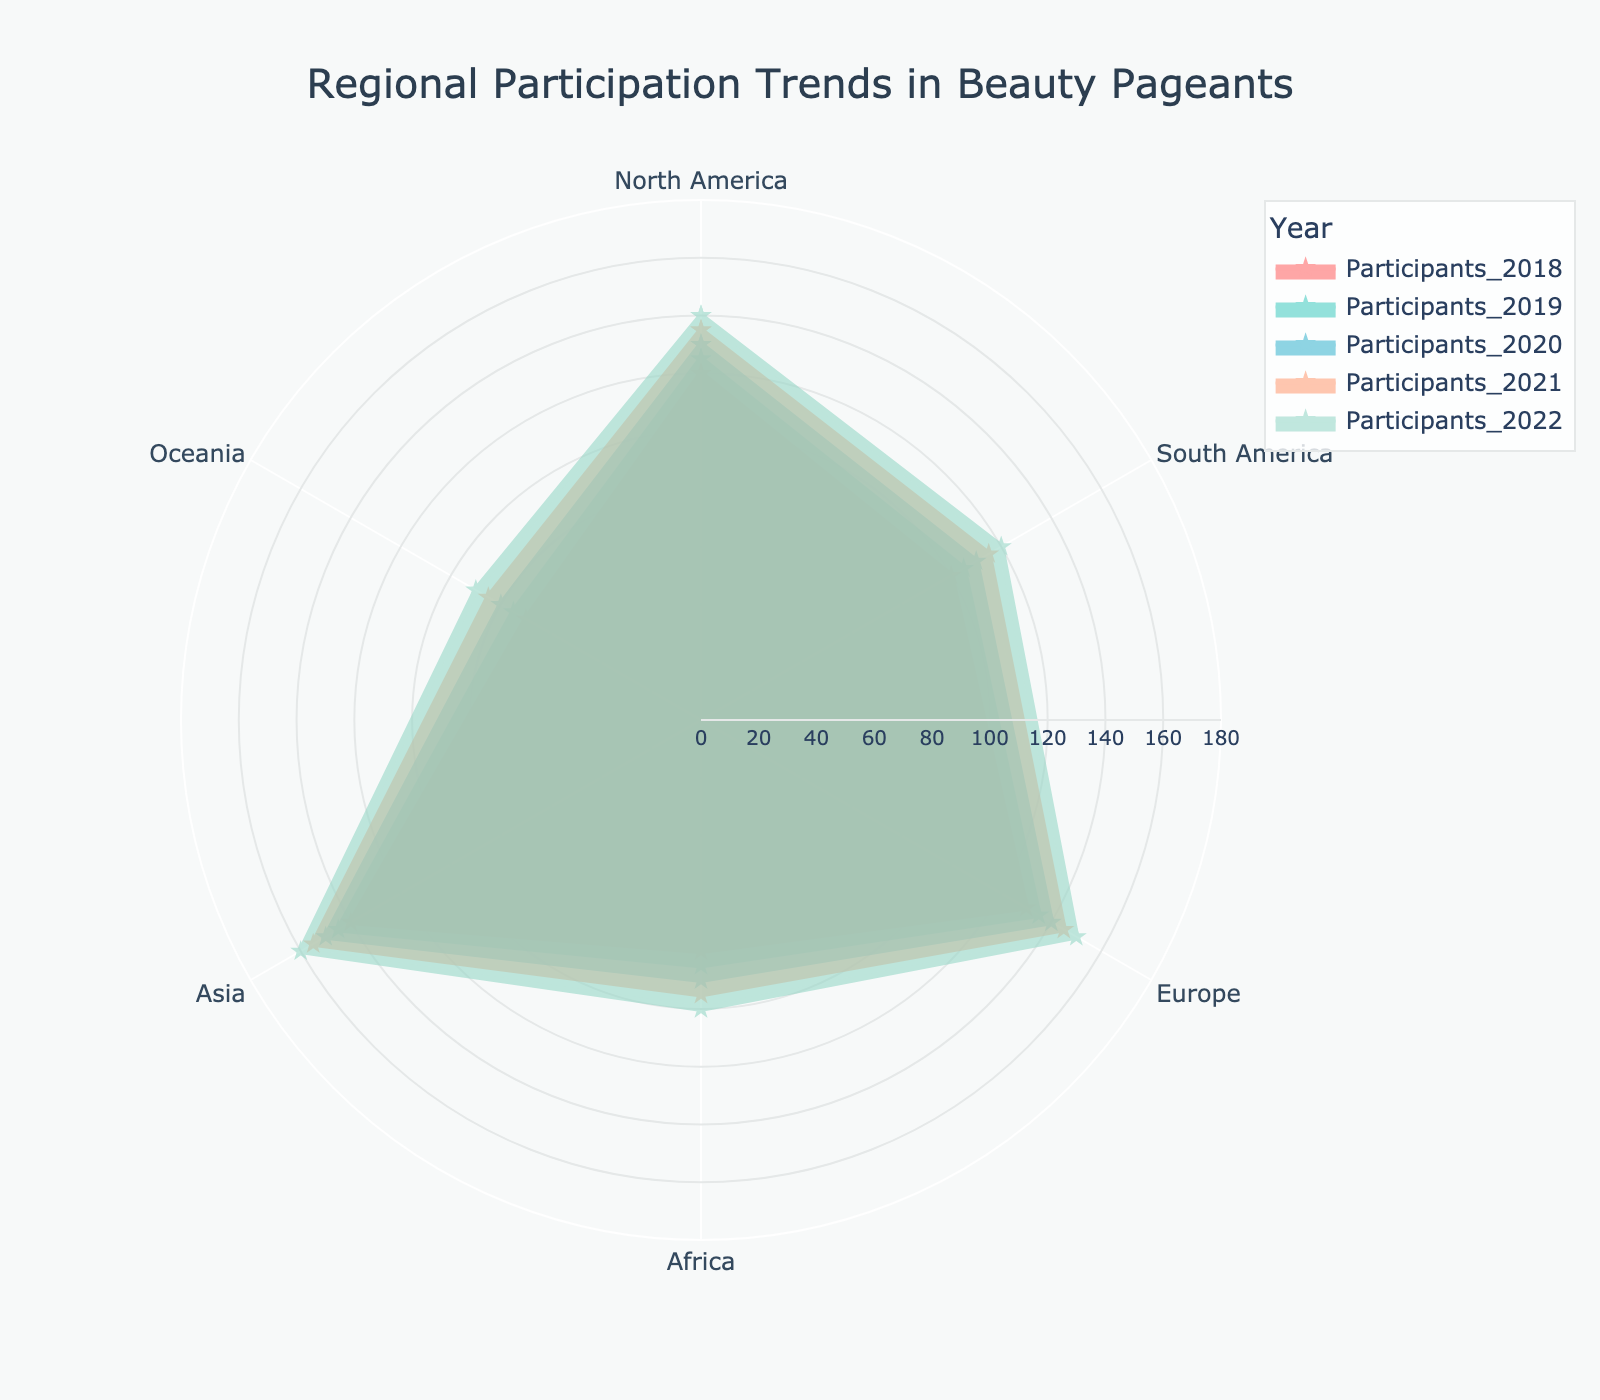what is the title of the chart? The title is given at the top of the figure in a prominent position, making it easy to identify. It reads "Regional Participation Trends in Beauty Pageants".
Answer: Regional Participation Trends in Beauty Pageants what regions are represented in the radar chart? The labels on the radar chart outline the regions, which include North America, South America, Europe, Africa, Asia, and Oceania.
Answer: North America, South America, Europe, Africa, Asia, Oceania Which region had the lowest participation in 2018? By looking at the outer point of each region in the 2018 trace, you can see that Oceania has the lowest value compared to other regions.
Answer: Oceania how many regions show an increase in participants from 2020 to 2022? By examining each region's points for 2020 and 2022, we can see that all regions (North America, South America, Europe, Africa, Asia, and Oceania) show an increase in participants over these years.
Answer: 6 Which year has the darkest colored line? The darkest colored line corresponds to the values for the year 2018. This can be observed by identifying the trace color and matching it with the legend.
Answer: 2018 did any region have participation numbers greater than 150 in any year? By inspecting the radial axis values for each year and region, we see that North America, Europe, and Asia had participation numbers greater than 150 in 2022.
Answer: Yes which region shows the steadiest increase in participants over the years? To determine the steadiest increase, observe the smoothness and even rise of the participation values across all years. Europe shows a consistent and steady increase year-on-year.
Answer: Europe what is the difference in participant numbers between North America and Oceania in 2020? North America had 130 participants and Oceania had 80 in 2020. The difference is calculated as 130 - 80.
Answer: 50 Which region had a participation number closest to 100 in 2021? By locating the 2021 trace and inspecting each region's value, Africa had a participation number closest to 100. It exactly had 95 participants.
Answer: Africa Between North America and Asia, which region had a greater increase in participants from 2018 to 2022? North America went from 120 to 140 (+20), while Asia went from 140 to 160 (+20) Thus, both regions had an equal increase in participants from 2018 to 2022.
Answer: Both equal 